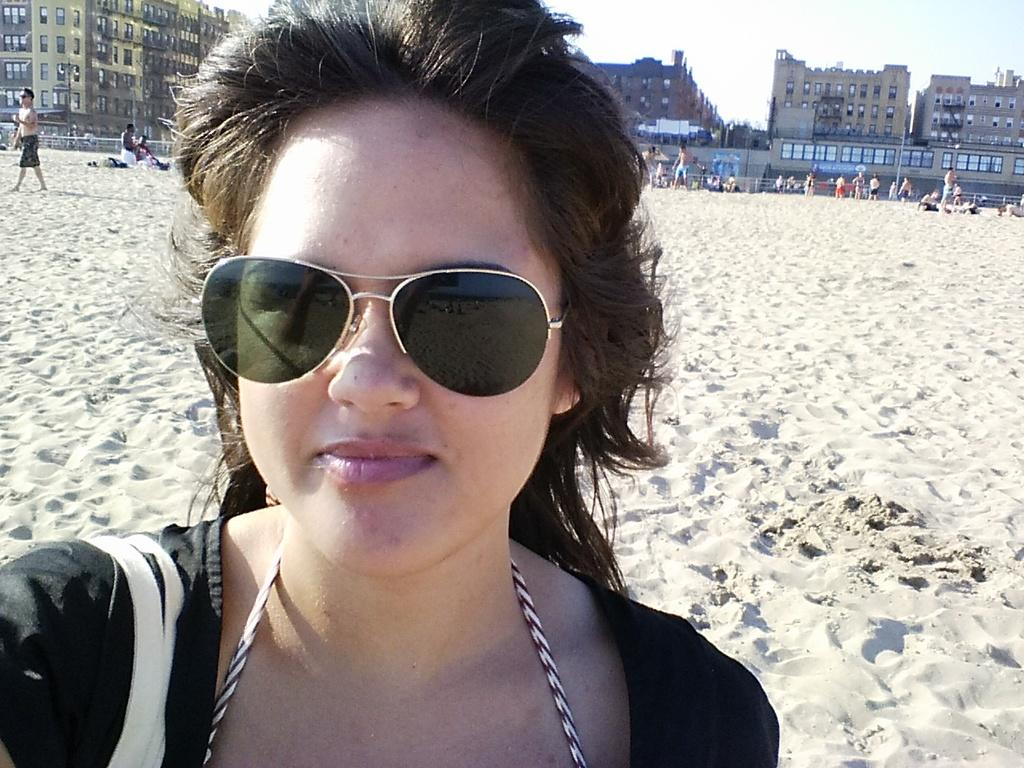Who is the main subject in the image? There is a lady in the center of the image. What is the lady wearing? The lady is wearing glasses. What can be seen in the background of the image? There are buildings and people in the background of the image. What is at the bottom of the image? There is sand at the bottom of the image. What type of fang can be seen in the lady's mouth in the image? There is no fang visible in the lady's mouth in the image. How does the lady fold the sand in the image? The lady is not folding the sand in the image; she is standing on it. 